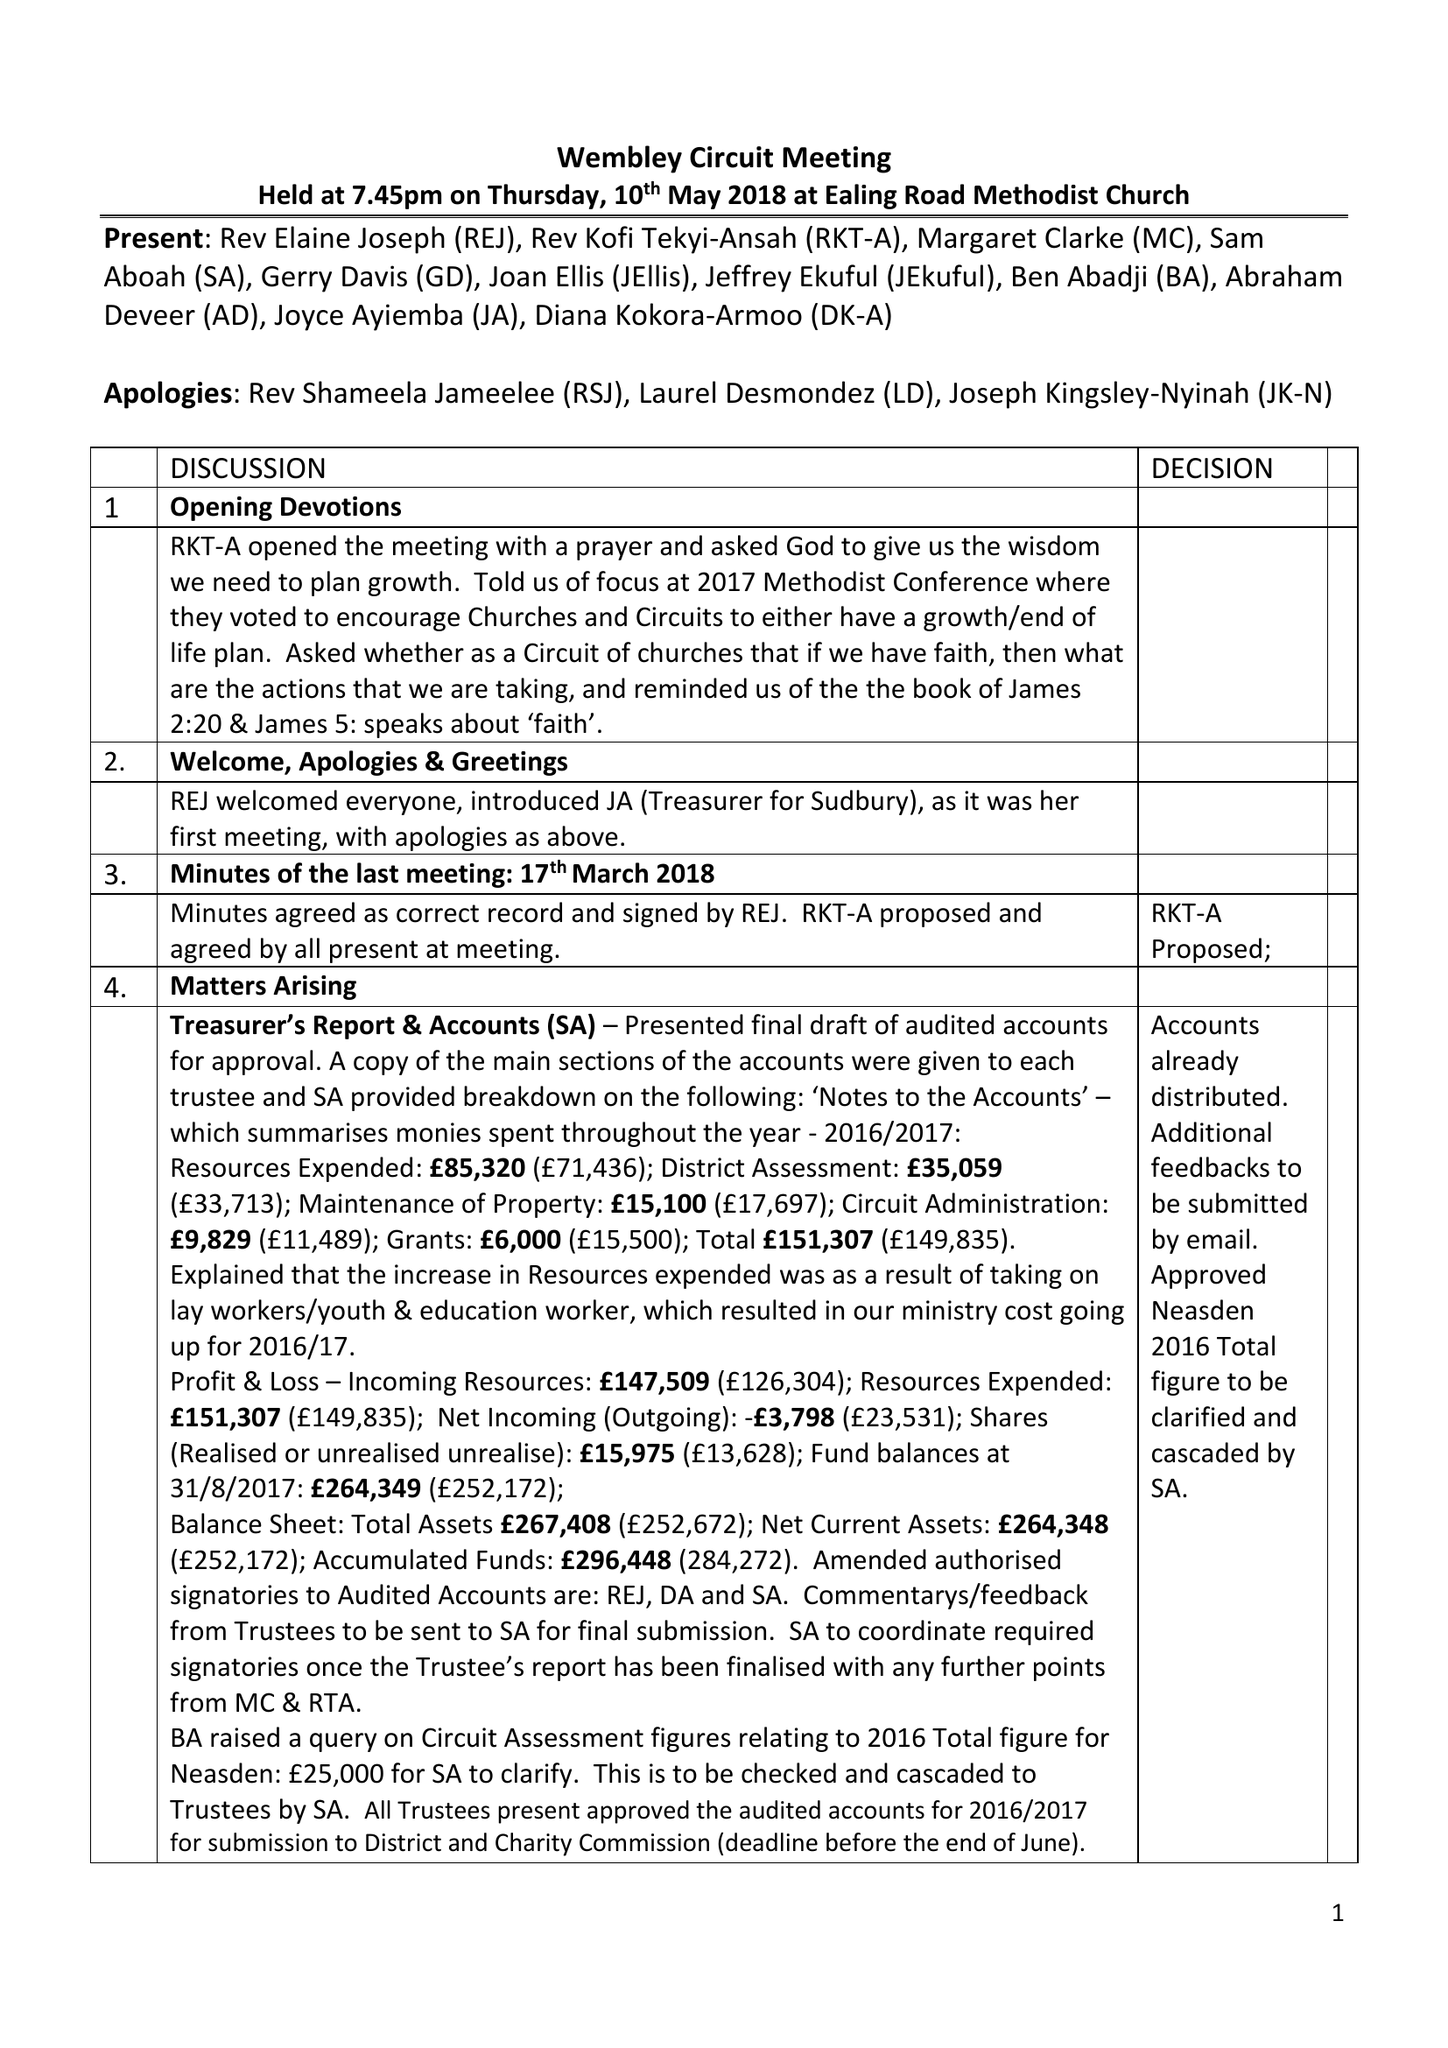What is the value for the report_date?
Answer the question using a single word or phrase. 2017-08-31 